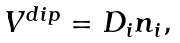Convert formula to latex. <formula><loc_0><loc_0><loc_500><loc_500>\begin{array} { l } V ^ { d i p } = D _ { i } n _ { i } , \end{array}</formula> 